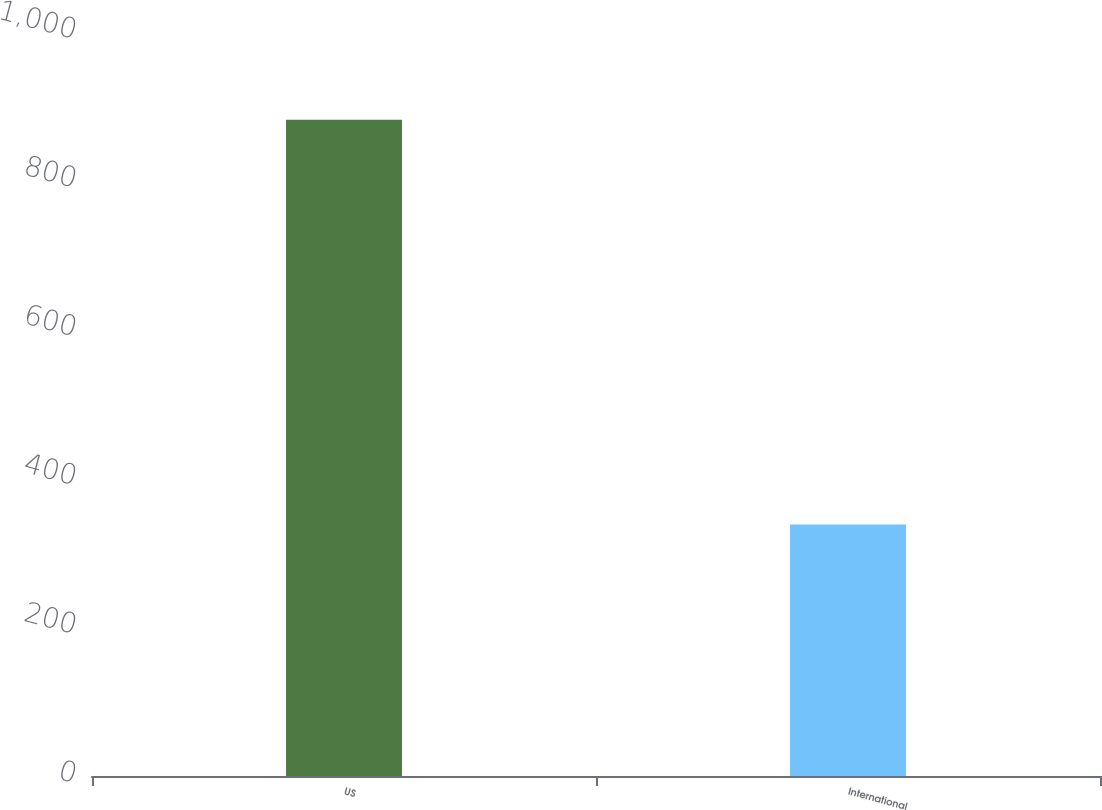Convert chart to OTSL. <chart><loc_0><loc_0><loc_500><loc_500><bar_chart><fcel>US<fcel>International<nl><fcel>882<fcel>338<nl></chart> 